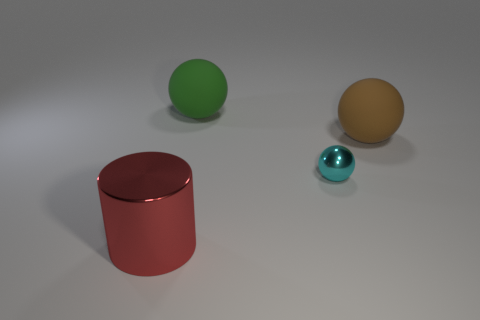Do the objects have any textures or are they smooth? The surfaces of all the objects appear smooth and lack any noticeable texture. The reflections and highlights, specifically on the red cylinder and cyan object, indicate a glossy or shiny material, often found in smooth finishes with little to no texture. 